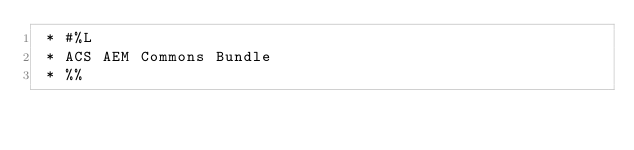Convert code to text. <code><loc_0><loc_0><loc_500><loc_500><_Java_> * #%L
 * ACS AEM Commons Bundle
 * %%</code> 